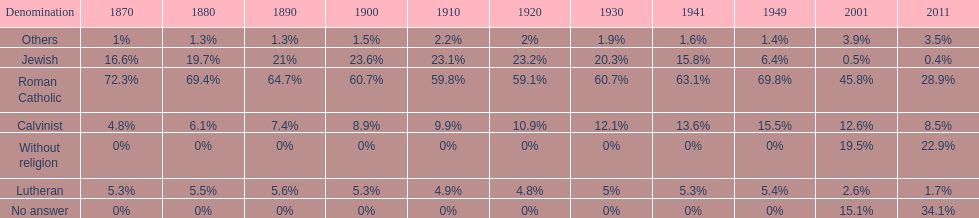Could you parse the entire table? {'header': ['Denomination', '1870', '1880', '1890', '1900', '1910', '1920', '1930', '1941', '1949', '2001', '2011'], 'rows': [['Others', '1%', '1.3%', '1.3%', '1.5%', '2.2%', '2%', '1.9%', '1.6%', '1.4%', '3.9%', '3.5%'], ['Jewish', '16.6%', '19.7%', '21%', '23.6%', '23.1%', '23.2%', '20.3%', '15.8%', '6.4%', '0.5%', '0.4%'], ['Roman Catholic', '72.3%', '69.4%', '64.7%', '60.7%', '59.8%', '59.1%', '60.7%', '63.1%', '69.8%', '45.8%', '28.9%'], ['Calvinist', '4.8%', '6.1%', '7.4%', '8.9%', '9.9%', '10.9%', '12.1%', '13.6%', '15.5%', '12.6%', '8.5%'], ['Without religion', '0%', '0%', '0%', '0%', '0%', '0%', '0%', '0%', '0%', '19.5%', '22.9%'], ['Lutheran', '5.3%', '5.5%', '5.6%', '5.3%', '4.9%', '4.8%', '5%', '5.3%', '5.4%', '2.6%', '1.7%'], ['No answer', '0%', '0%', '0%', '0%', '0%', '0%', '0%', '0%', '0%', '15.1%', '34.1%']]} Which denomination percentage increased the most after 1949? Without religion. 